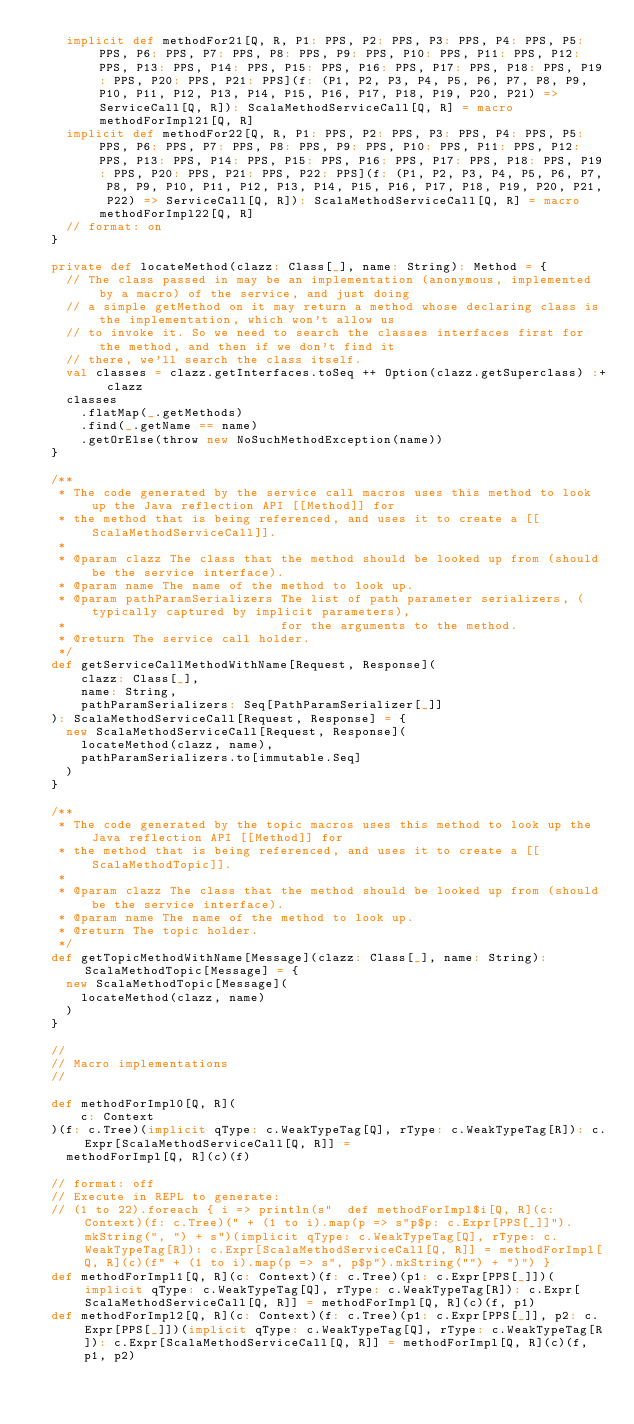<code> <loc_0><loc_0><loc_500><loc_500><_Scala_>    implicit def methodFor21[Q, R, P1: PPS, P2: PPS, P3: PPS, P4: PPS, P5: PPS, P6: PPS, P7: PPS, P8: PPS, P9: PPS, P10: PPS, P11: PPS, P12: PPS, P13: PPS, P14: PPS, P15: PPS, P16: PPS, P17: PPS, P18: PPS, P19: PPS, P20: PPS, P21: PPS](f: (P1, P2, P3, P4, P5, P6, P7, P8, P9, P10, P11, P12, P13, P14, P15, P16, P17, P18, P19, P20, P21) => ServiceCall[Q, R]): ScalaMethodServiceCall[Q, R] = macro methodForImpl21[Q, R]
    implicit def methodFor22[Q, R, P1: PPS, P2: PPS, P3: PPS, P4: PPS, P5: PPS, P6: PPS, P7: PPS, P8: PPS, P9: PPS, P10: PPS, P11: PPS, P12: PPS, P13: PPS, P14: PPS, P15: PPS, P16: PPS, P17: PPS, P18: PPS, P19: PPS, P20: PPS, P21: PPS, P22: PPS](f: (P1, P2, P3, P4, P5, P6, P7, P8, P9, P10, P11, P12, P13, P14, P15, P16, P17, P18, P19, P20, P21, P22) => ServiceCall[Q, R]): ScalaMethodServiceCall[Q, R] = macro methodForImpl22[Q, R]
    // format: on
  }

  private def locateMethod(clazz: Class[_], name: String): Method = {
    // The class passed in may be an implementation (anonymous, implemented by a macro) of the service, and just doing
    // a simple getMethod on it may return a method whose declaring class is the implementation, which won't allow us
    // to invoke it. So we need to search the classes interfaces first for the method, and then if we don't find it
    // there, we'll search the class itself.
    val classes = clazz.getInterfaces.toSeq ++ Option(clazz.getSuperclass) :+ clazz
    classes
      .flatMap(_.getMethods)
      .find(_.getName == name)
      .getOrElse(throw new NoSuchMethodException(name))
  }

  /**
   * The code generated by the service call macros uses this method to look up the Java reflection API [[Method]] for
   * the method that is being referenced, and uses it to create a [[ScalaMethodServiceCall]].
   *
   * @param clazz The class that the method should be looked up from (should be the service interface).
   * @param name The name of the method to look up.
   * @param pathParamSerializers The list of path parameter serializers, (typically captured by implicit parameters),
   *                             for the arguments to the method.
   * @return The service call holder.
   */
  def getServiceCallMethodWithName[Request, Response](
      clazz: Class[_],
      name: String,
      pathParamSerializers: Seq[PathParamSerializer[_]]
  ): ScalaMethodServiceCall[Request, Response] = {
    new ScalaMethodServiceCall[Request, Response](
      locateMethod(clazz, name),
      pathParamSerializers.to[immutable.Seq]
    )
  }

  /**
   * The code generated by the topic macros uses this method to look up the Java reflection API [[Method]] for
   * the method that is being referenced, and uses it to create a [[ScalaMethodTopic]].
   *
   * @param clazz The class that the method should be looked up from (should be the service interface).
   * @param name The name of the method to look up.
   * @return The topic holder.
   */
  def getTopicMethodWithName[Message](clazz: Class[_], name: String): ScalaMethodTopic[Message] = {
    new ScalaMethodTopic[Message](
      locateMethod(clazz, name)
    )
  }

  //
  // Macro implementations
  //

  def methodForImpl0[Q, R](
      c: Context
  )(f: c.Tree)(implicit qType: c.WeakTypeTag[Q], rType: c.WeakTypeTag[R]): c.Expr[ScalaMethodServiceCall[Q, R]] =
    methodForImpl[Q, R](c)(f)

  // format: off
  // Execute in REPL to generate:
  // (1 to 22).foreach { i => println(s"  def methodForImpl$i[Q, R](c: Context)(f: c.Tree)(" + (1 to i).map(p => s"p$p: c.Expr[PPS[_]]").mkString(", ") + s")(implicit qType: c.WeakTypeTag[Q], rType: c.WeakTypeTag[R]): c.Expr[ScalaMethodServiceCall[Q, R]] = methodForImpl[Q, R](c)(f" + (1 to i).map(p => s", p$p").mkString("") + ")") }
  def methodForImpl1[Q, R](c: Context)(f: c.Tree)(p1: c.Expr[PPS[_]])(implicit qType: c.WeakTypeTag[Q], rType: c.WeakTypeTag[R]): c.Expr[ScalaMethodServiceCall[Q, R]] = methodForImpl[Q, R](c)(f, p1)
  def methodForImpl2[Q, R](c: Context)(f: c.Tree)(p1: c.Expr[PPS[_]], p2: c.Expr[PPS[_]])(implicit qType: c.WeakTypeTag[Q], rType: c.WeakTypeTag[R]): c.Expr[ScalaMethodServiceCall[Q, R]] = methodForImpl[Q, R](c)(f, p1, p2)</code> 